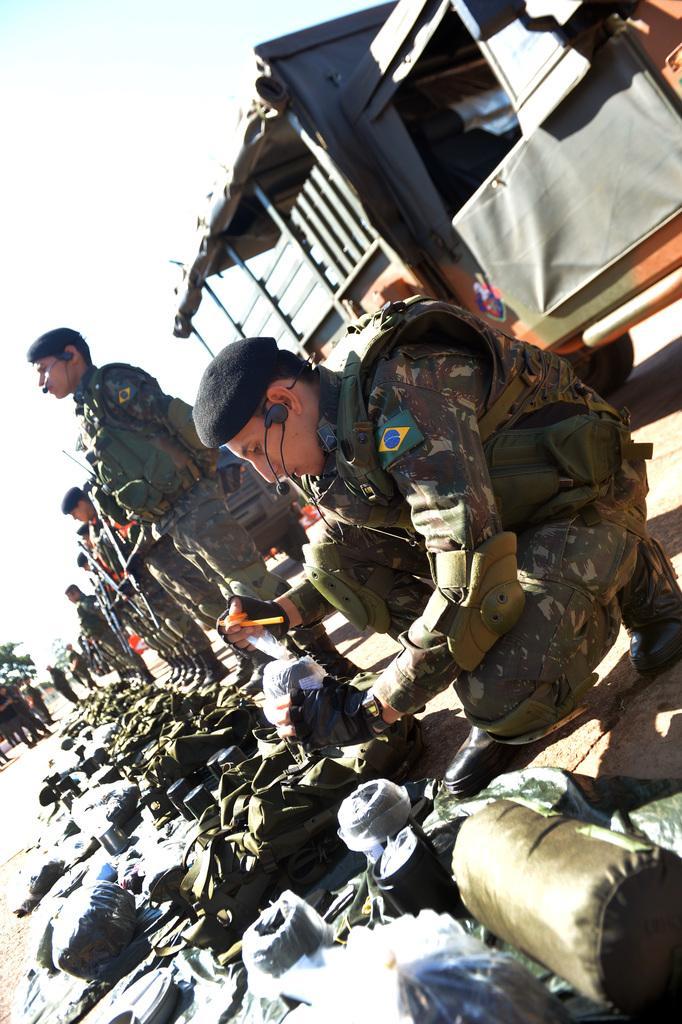Can you describe this image briefly? In this image there are few people on the road, wearing uniforms and some of them are holding guns, there are few objects on the ground, a vehicle and trees. 